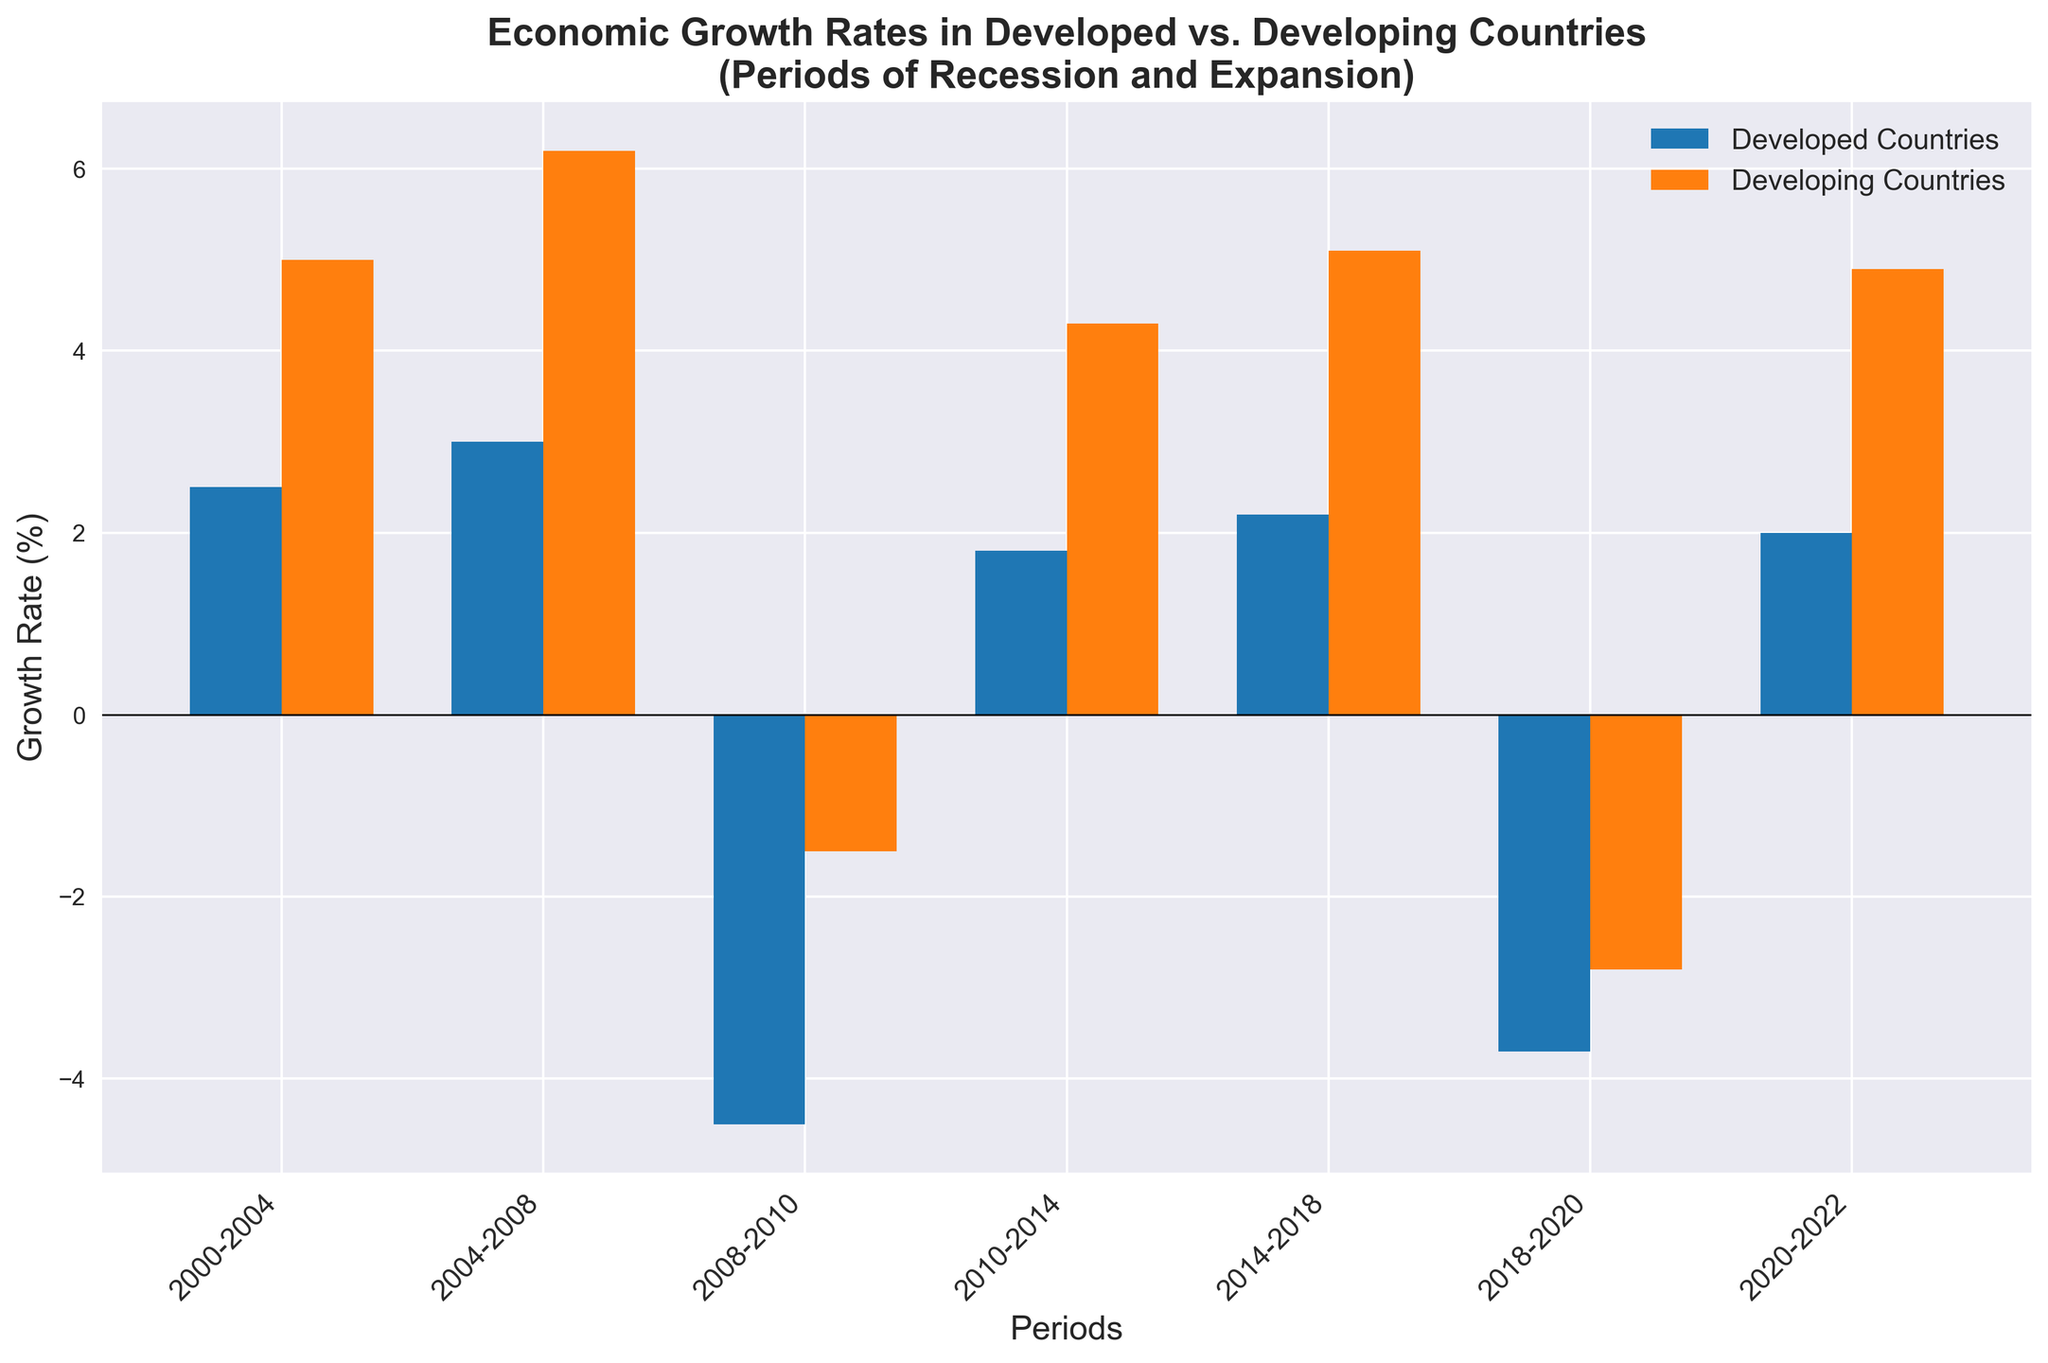What period shows the highest growth rate for developed countries during an expansion? First, identify the periods of expansion for developed countries from the bar chart. Then compare the growth rates for these periods. The highest growth rate during an expansion for developed countries is in the period 2004-2008 with a rate of 3.0%.
Answer: 2004-2008 What is the difference in growth rates between developed and developing countries during the 2008-2010 recession? Locate the growth rates for both developed and developing countries during the 2008-2010 recession from the bar chart. The growth rate for developed countries is -4.5% and for developing countries is -1.5%. The difference is -4.5% - (-1.5%) = -3%.
Answer: -3% During which period did developing countries experience their lowest growth rate? Scan the bar chart for growth rates of developing countries and find the lowest value. The lowest growth rate for developing countries occurs during the 2008-2010 recession with a rate of -1.5%.
Answer: 2008-2010 How do the growth rates of developing and developed countries compare during the 2018-2020 recession? Look at the growth rates for both developed and developing countries during the 2018-2020 recession. The growth rate for developed countries is -3.7% and for developing countries is -2.8%. The developed countries have a lower (more negative) growth rate compared to developing countries.
Answer: Developed countries have a lower growth rate What is the average growth rate for developing countries during the periods of expansion? Identify the growth rates during expansions for developing countries: 5.0%, 6.2%, 4.3%, 5.1%, and 4.9%. Calculate the average: (5.0 + 6.2 + 4.3 + 5.1 + 4.9) / 5 = 25.5 / 5 = 5.1%.
Answer: 5.1% Which color represents developed countries in the bar chart, and what is their average growth rate during recessions? The bars representing developed countries are blue. Identify the growth rates during recessions for developed countries: -4.5% (2008-2010) and -3.7% (2018-2020). Calculate their average: (-4.5 + -3.7) / 2 = -4.1%.
Answer: Blue. -4.1% During the 2010-2014 expansion period, is the growth rate higher for developed or developing countries? Compare the growth rates for developed and developing countries during the 2010-2014 expansion. Developed countries have a growth rate of 1.8%, and developing countries have a growth rate of 4.3%. The developing countries have a higher growth rate.
Answer: Developing countries What is the total growth rate for developed countries across all periods of recession? Identify and sum the growth rates during recessions for developed countries: -4.5% (2008-2010) and -3.7% (2018-2020). The total growth rate is -4.5 + -3.7 = -8.2%.
Answer: -8.2% Which period recorded a higher growth rate in developing countries compared to developed countries? Compare the growth rates for each period. Developing countries have a higher growth rate than developed countries in 2000-2004 (5.0% vs 2.5%), 2004-2008 (6.2% vs 3.0%), 2010-2014 (4.3% vs 1.8%), 2014-2018 (5.1% vs 2.2%), and 2020-2022 (4.9% vs 2.0%).
Answer: 2000-2004, 2004-2008, 2010-2014, 2014-2018, 2020-2022 